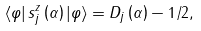Convert formula to latex. <formula><loc_0><loc_0><loc_500><loc_500>\left \langle \varphi \right | s _ { j } ^ { z } \left ( \alpha \right ) \left | \varphi \right \rangle = D _ { j } \left ( \alpha \right ) - 1 / 2 ,</formula> 